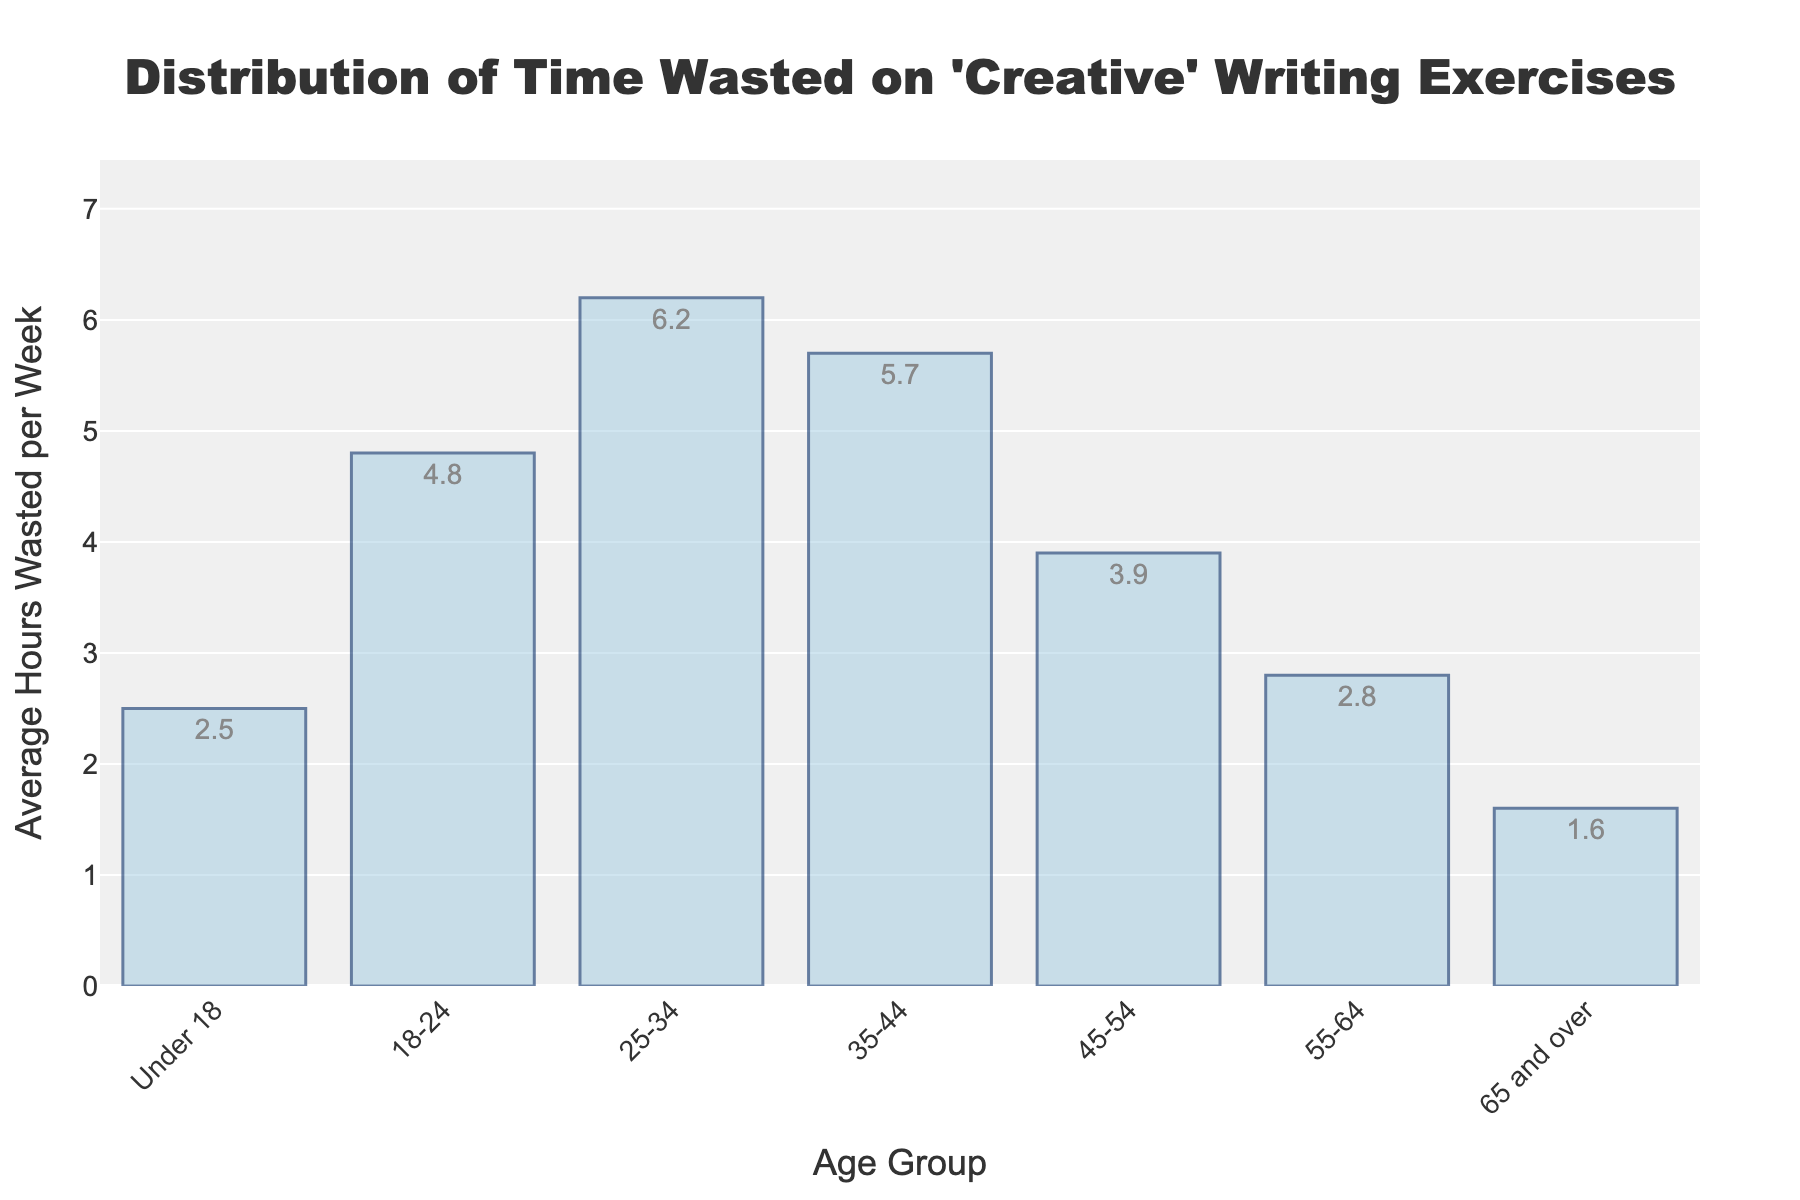What is the age group with the highest average hours wasted per week? The bar representing the 25-34 age group is the tallest, indicating that this age group wastes the most time per week.
Answer: 25-34 How much more time does the 25-34 age group waste compared to the 65 and over age group? The average for the 25-34 age group is 6.2 hours, and for the 65 and over age group is 1.6 hours. Subtract 1.6 from 6.2 to get the difference.
Answer: 4.6 hours Which age groups waste less than 3 hours per week on average? The bars for the Under 18, 55-64, and 65 and over age groups are all below the 3-hour mark.
Answer: Under 18, 55-64, 65 and over What is the combined average hours wasted per week for the 18-24 and 35-44 age groups? The average for 18-24 is 4.8 hours, and for 35-44 is 5.7 hours. Add these two values together.
Answer: 10.5 hours Does the average time wasted per week increase or decrease as people get older? The chart shows a peak around the 25-34 age group and generally decreases after that.
Answer: Decrease What is the difference in average hours wasted per week between the 18-24 age group and the 45-54 age group? Subtract the average for the 45-54 group (3.9) from the average for the 18-24 group (4.8).
Answer: 0.9 hours Which age group wastes slightly less time than the 25-34 age group? The bar for 35-44 is slightly shorter than the 25-34 group, indicating it wastes slightly less time.
Answer: 35-44 How many age groups waste more than 4 hours per week on average? The bars representing the 18-24, 25-34, and 35-44 age groups are above the 4-hour mark.
Answer: 3 What is the second highest amount of time wasted per week? The second tallest bar is for the 35-44 age group, which indicates an average of 5.7 hours.
Answer: 5.7 hours Which age group wastes almost double the time of the 65 and over age group? The bar for 18-24 shows 4.8 hours, which is almost three times more than 1.6 hours for 65 and over.
Answer: 18-24 